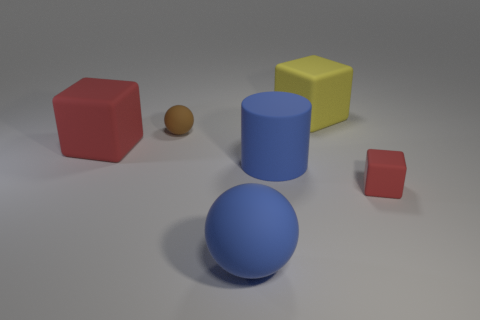What colors are the objects in the image? The objects present in the image consist of the following colors: there is a red cube, a blue cylinder, a large blue sphere, a yellow cube, and a tiny brown ball. The background is a neutral gray tone. 